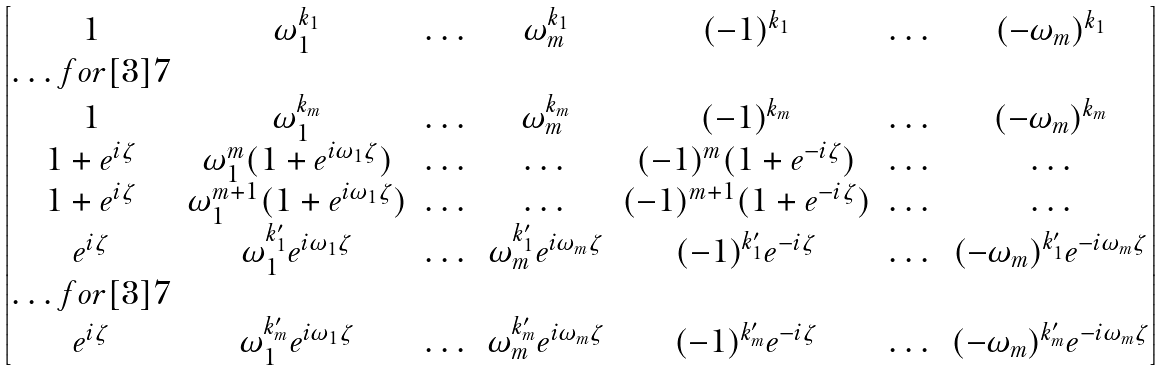<formula> <loc_0><loc_0><loc_500><loc_500>\begin{bmatrix} 1 & \omega _ { 1 } ^ { k _ { 1 } } & \dots & \omega _ { m } ^ { k _ { 1 } } & ( - 1 ) ^ { k _ { 1 } } & \dots & ( - \omega _ { m } ) ^ { k _ { 1 } } \\ \hdots f o r [ 3 ] { 7 } \\ 1 & \omega _ { 1 } ^ { k _ { m } } & \dots & \omega _ { m } ^ { k _ { m } } & ( - 1 ) ^ { k _ { m } } & \dots & ( - \omega _ { m } ) ^ { k _ { m } } \\ 1 + e ^ { i \zeta } & \omega _ { 1 } ^ { m } ( 1 + e ^ { i \omega _ { 1 } \zeta } ) & \dots & \dots & ( - 1 ) ^ { m } ( 1 + e ^ { - i \zeta } ) & \dots & \dots \\ 1 + e ^ { i \zeta } & \omega _ { 1 } ^ { m + 1 } ( 1 + e ^ { i \omega _ { 1 } \zeta } ) & \dots & \dots & ( - 1 ) ^ { m + 1 } ( 1 + e ^ { - i \zeta } ) & \dots & \dots \\ e ^ { i \zeta } & \omega _ { 1 } ^ { k ^ { \prime } _ { 1 } } e ^ { i \omega _ { 1 } \zeta } & \dots & \omega _ { m } ^ { k ^ { \prime } _ { 1 } } e ^ { i \omega _ { m } \zeta } & ( - 1 ) ^ { k ^ { \prime } _ { 1 } } e ^ { - i \zeta } & \dots & ( - \omega _ { m } ) ^ { k ^ { \prime } _ { 1 } } e ^ { - i \omega _ { m } \zeta } \\ \hdots f o r [ 3 ] { 7 } \\ e ^ { i \zeta } & \omega _ { 1 } ^ { k ^ { \prime } _ { m } } e ^ { i \omega _ { 1 } \zeta } & \dots & \omega _ { m } ^ { k ^ { \prime } _ { m } } e ^ { i \omega _ { m } \zeta } & ( - 1 ) ^ { k ^ { \prime } _ { m } } e ^ { - i \zeta } & \dots & ( - \omega _ { m } ) ^ { k ^ { \prime } _ { m } } e ^ { - i \omega _ { m } \zeta } \\ \end{bmatrix}</formula> 